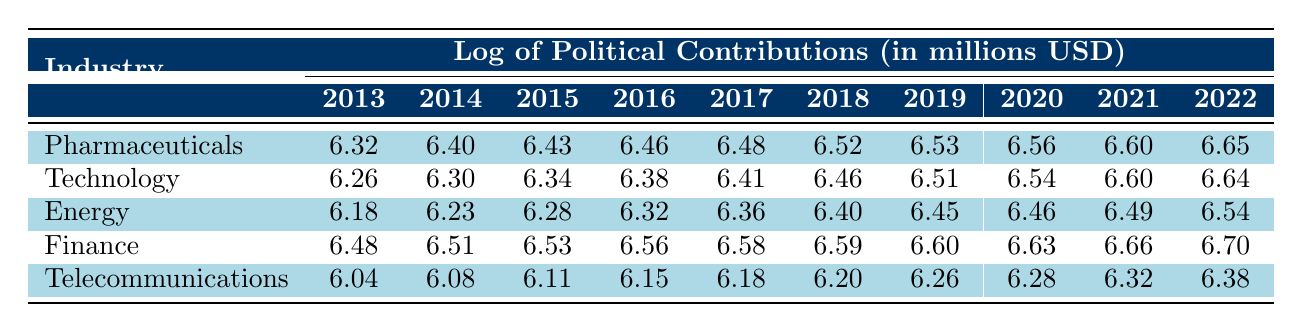What was the total political contribution from the Finance industry in 2022? From the table, the value for Finance in 2022 is 6.70 (in log value). Converting this back to actual contributions involves calculating 10^6.70, which is approximately 5,000,000 USD.
Answer: 5,000,000 USD Which industry had the highest political contributions in 2018? Looking at the values for 2018: Pharmaceuticals is 6.52, Technology is 6.46, Energy is 6.40, Finance is 6.59, and Telecommunications is 6.20. Finance has the highest value at 6.59.
Answer: Finance What was the average political contribution from the Telecommunications industry over the decade? To find the average, we sum all the values for Telecommunications from 2013 to 2022: (6.04 + 6.08 + 6.11 + 6.15 + 6.18 + 6.20 + 6.26 + 6.28 + 6.32 + 6.38) = 62.1. Dividing by the 10 years gives an average of 62.1/10 = 6.21.
Answer: 6.21 Did the Energy industry's contributions increase every year from 2013 to 2022? The values for the Energy industry in each year are increasing from 6.18 in 2013 to 6.54 in 2022, indicating consistent growth without any decrease.
Answer: Yes Which industry showed the smallest increase in contributions from 2019 to 2020? Analyzing the years 2019 and 2020: Pharmaceuticals increased from 6.53 to 6.56 (0.03), Technology from 6.51 to 6.54 (0.03), Energy from 6.45 to 6.46 (0.01), Finance from 6.60 to 6.63 (0.03), and Telecommunications from 6.26 to 6.28 (0.02). Energy showed the smallest increase of 0.01.
Answer: Energy 